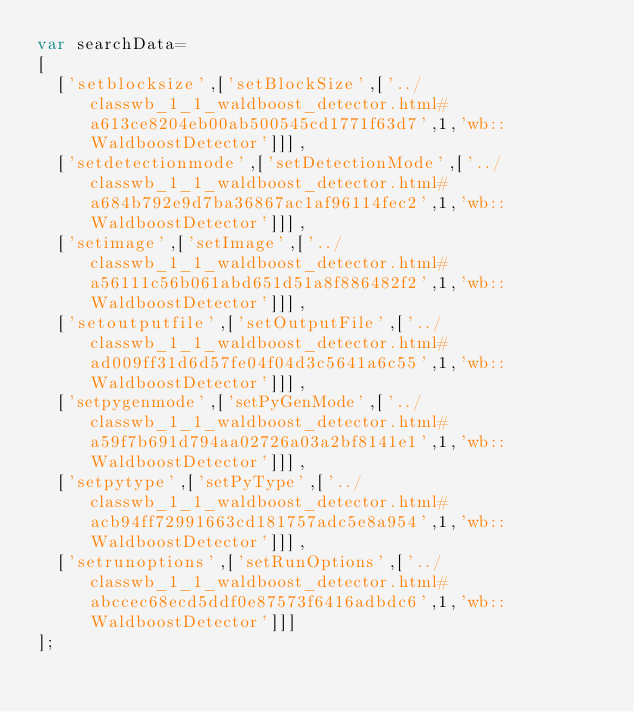Convert code to text. <code><loc_0><loc_0><loc_500><loc_500><_JavaScript_>var searchData=
[
  ['setblocksize',['setBlockSize',['../classwb_1_1_waldboost_detector.html#a613ce8204eb00ab500545cd1771f63d7',1,'wb::WaldboostDetector']]],
  ['setdetectionmode',['setDetectionMode',['../classwb_1_1_waldboost_detector.html#a684b792e9d7ba36867ac1af96114fec2',1,'wb::WaldboostDetector']]],
  ['setimage',['setImage',['../classwb_1_1_waldboost_detector.html#a56111c56b061abd651d51a8f886482f2',1,'wb::WaldboostDetector']]],
  ['setoutputfile',['setOutputFile',['../classwb_1_1_waldboost_detector.html#ad009ff31d6d57fe04f04d3c5641a6c55',1,'wb::WaldboostDetector']]],
  ['setpygenmode',['setPyGenMode',['../classwb_1_1_waldboost_detector.html#a59f7b691d794aa02726a03a2bf8141e1',1,'wb::WaldboostDetector']]],
  ['setpytype',['setPyType',['../classwb_1_1_waldboost_detector.html#acb94ff72991663cd181757adc5e8a954',1,'wb::WaldboostDetector']]],
  ['setrunoptions',['setRunOptions',['../classwb_1_1_waldboost_detector.html#abccec68ecd5ddf0e87573f6416adbdc6',1,'wb::WaldboostDetector']]]
];
</code> 